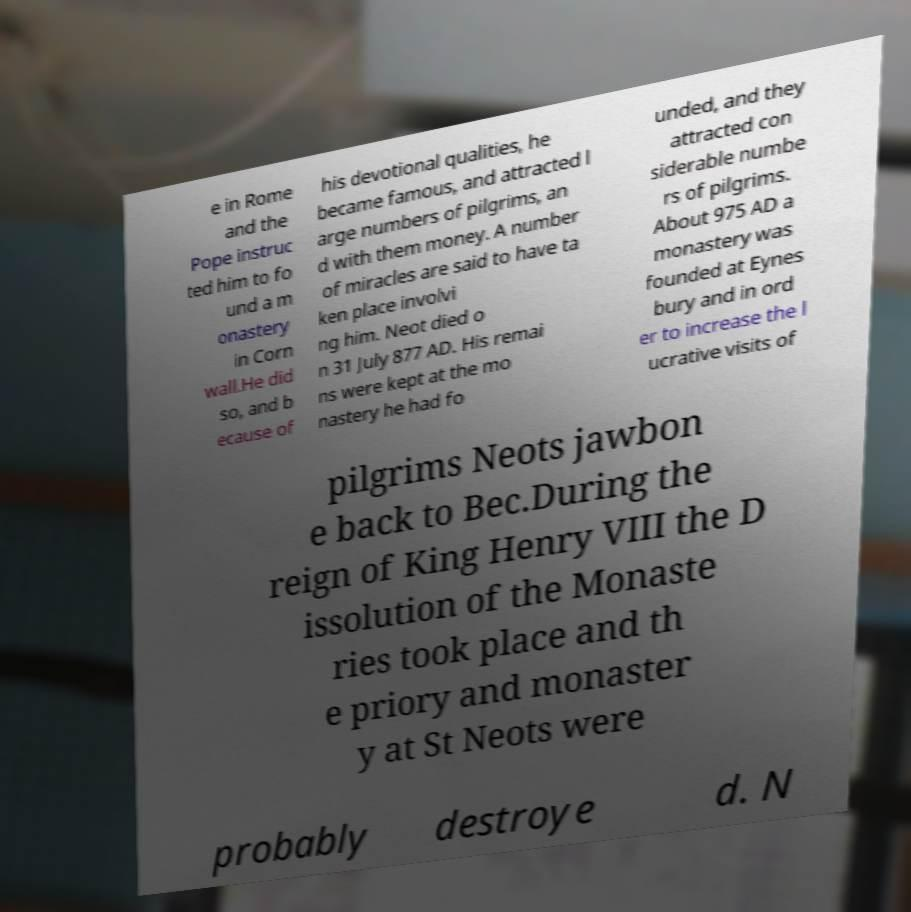Can you accurately transcribe the text from the provided image for me? e in Rome and the Pope instruc ted him to fo und a m onastery in Corn wall.He did so, and b ecause of his devotional qualities, he became famous, and attracted l arge numbers of pilgrims, an d with them money. A number of miracles are said to have ta ken place involvi ng him. Neot died o n 31 July 877 AD. His remai ns were kept at the mo nastery he had fo unded, and they attracted con siderable numbe rs of pilgrims. About 975 AD a monastery was founded at Eynes bury and in ord er to increase the l ucrative visits of pilgrims Neots jawbon e back to Bec.During the reign of King Henry VIII the D issolution of the Monaste ries took place and th e priory and monaster y at St Neots were probably destroye d. N 